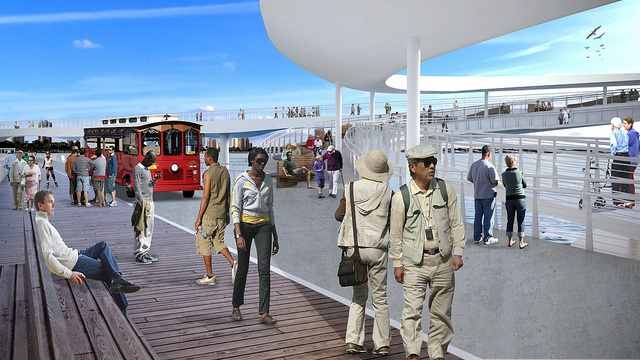Describe the objects in this image and their specific colors. I can see people in lightblue, darkgray, gray, black, and lightgray tones, people in lightblue, darkgray, gray, and lightgray tones, people in lightblue, darkgray, lightgray, and gray tones, bench in lightblue, gray, and black tones, and bus in lightblue, black, brown, maroon, and gray tones in this image. 